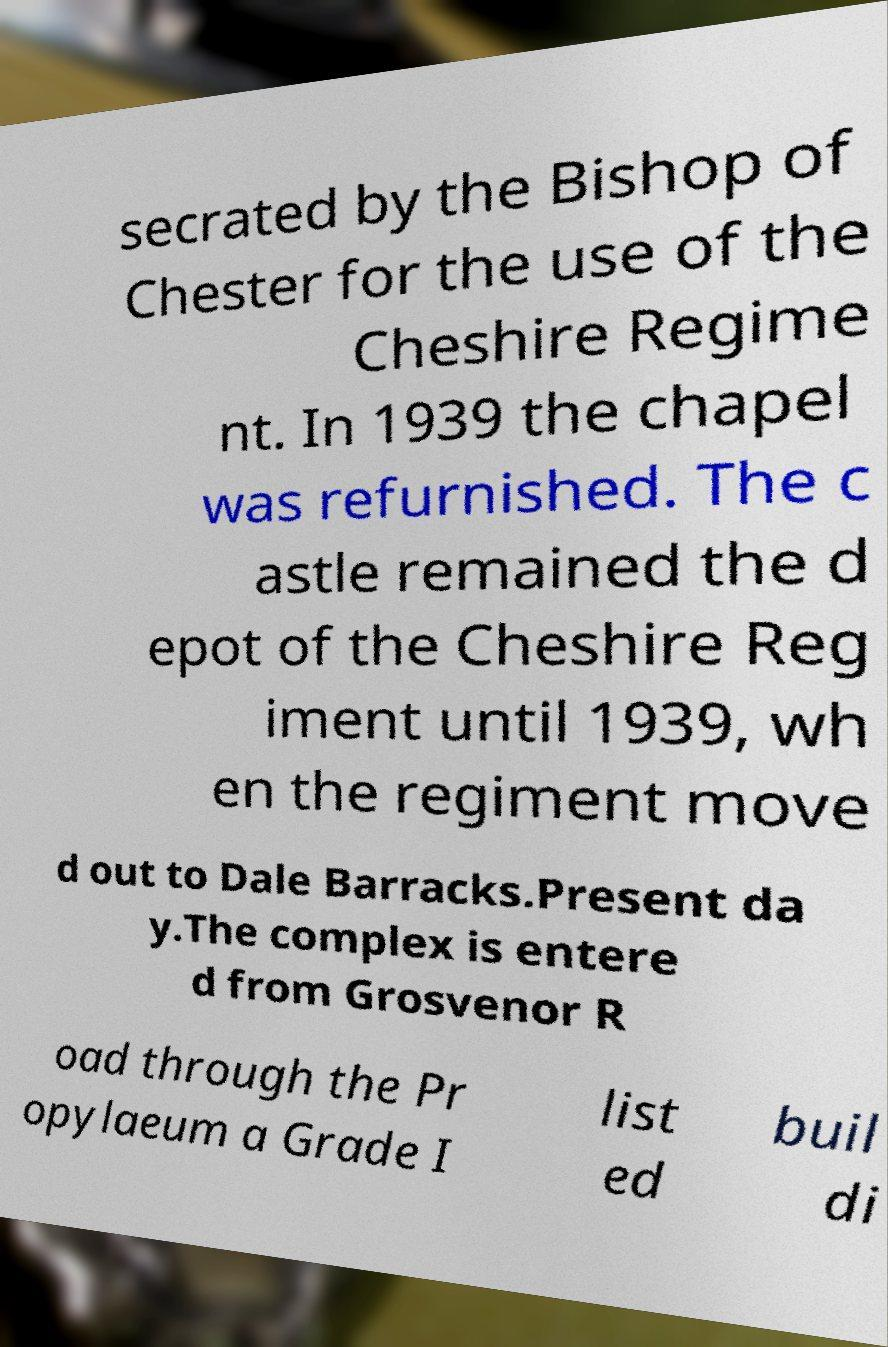What messages or text are displayed in this image? I need them in a readable, typed format. secrated by the Bishop of Chester for the use of the Cheshire Regime nt. In 1939 the chapel was refurnished. The c astle remained the d epot of the Cheshire Reg iment until 1939, wh en the regiment move d out to Dale Barracks.Present da y.The complex is entere d from Grosvenor R oad through the Pr opylaeum a Grade I list ed buil di 